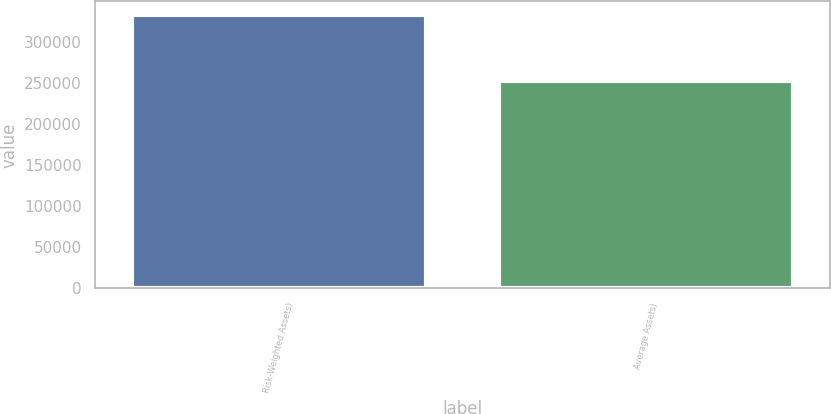Convert chart to OTSL. <chart><loc_0><loc_0><loc_500><loc_500><bar_chart><fcel>Risk-Weighted Assets)<fcel>Average Assets)<nl><fcel>332832<fcel>253048<nl></chart> 